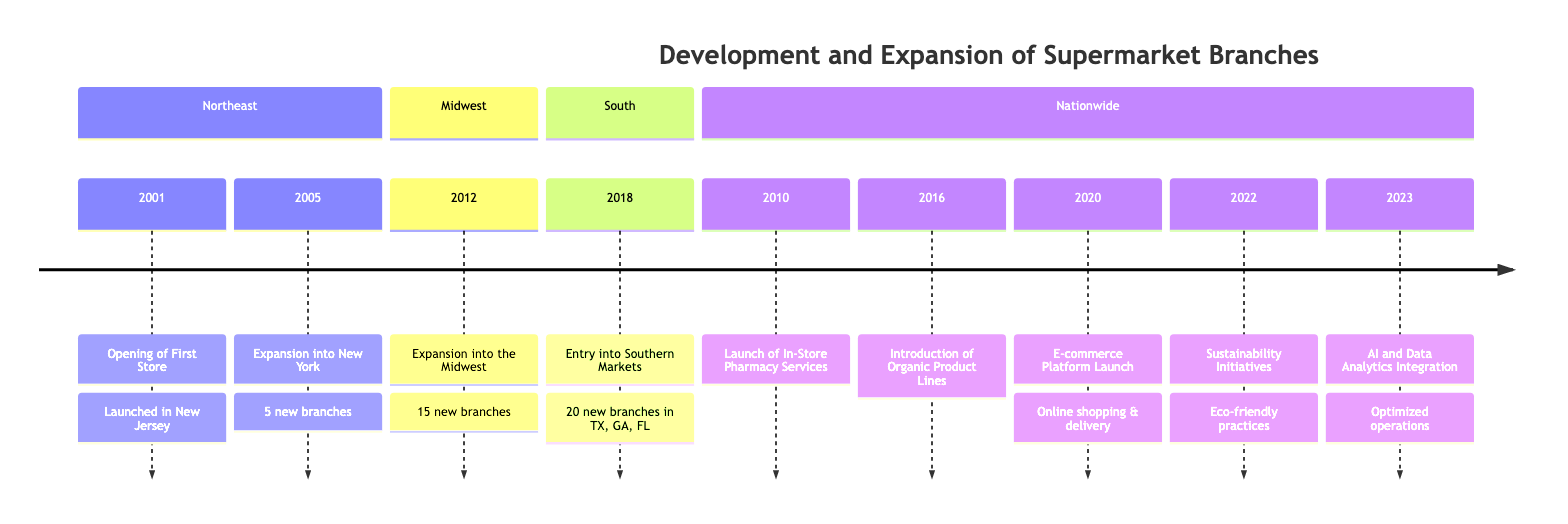What year was the first store opened? The diagram indicates that the first store was opened in the year 2001.
Answer: 2001 How many branches were opened in New York City in 2005? The diagram specifies that five new branches were opened in New York City in 2005.
Answer: 5 What new service was launched in 2010? According to the diagram, the new service introduced in 2010 was in-store pharmacy services.
Answer: In-Store Pharmacy Services How many new branches were established in southern markets in 2018? The diagram states that 20 new branches were established in southern markets during 2018.
Answer: 20 In which year did the supermarket chain begin its Midwest expansion? The diagram shows that the expansion into the Midwest began in the year 2012.
Answer: 2012 What is one reason for the introduction of organic product lines in 2016? The reason noted in the timeline for the introduction of organic product lines is to meet growing consumer demand for healthier options.
Answer: Meet growing consumer demand How many years apart were the launches of the e-commerce platform and in-store pharmacy services? The e-commerce platform was launched in 2020, while in-store pharmacy services were launched in 2010. Thus, the gap is 10 years.
Answer: 10 years Which region saw the supermarket's expansion in 2018? The diagram indicates that the supermarket expanded into the southern markets in 2018.
Answer: Southern Markets What was implemented in 2022 to promote eco-friendly practices? The sustainability initiatives implemented in 2022 included reducing plastic use, promoting recyclable packaging, and sourcing from sustainable farms.
Answer: Sustainability Initiatives 